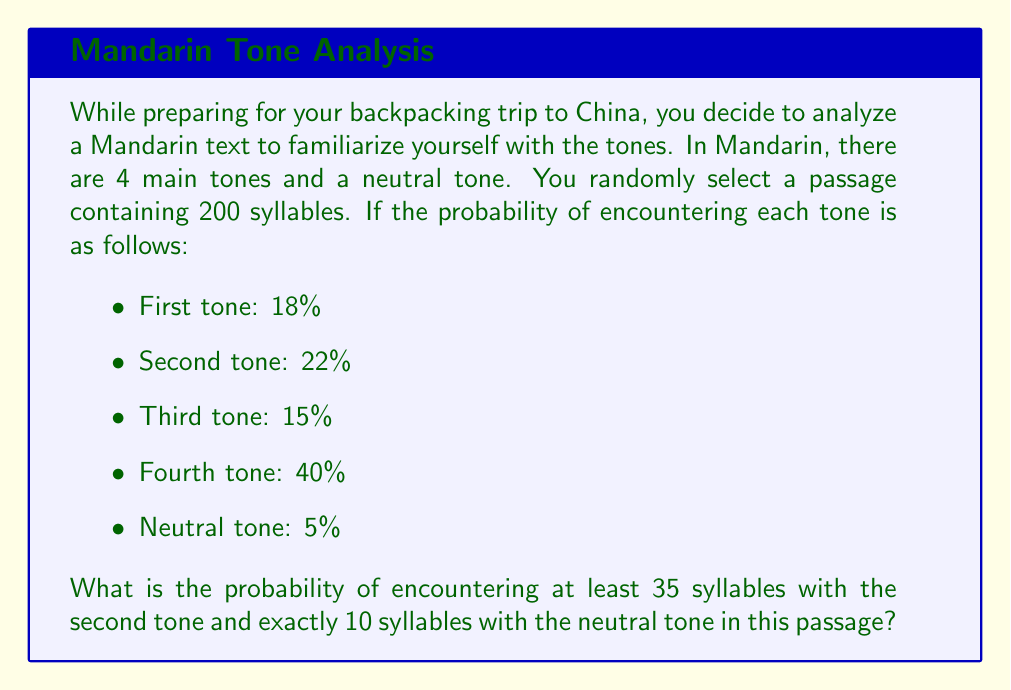Provide a solution to this math problem. Let's approach this step-by-step using the binomial distribution and the multiplication rule of probability:

1) For the second tone:
   - We want at least 35 syllables out of 200
   - Probability of second tone = 22% = 0.22
   - Let X be the number of second tone syllables
   
   P(X ≥ 35) = 1 - P(X < 35)
   
   We can calculate this using the cumulative binomial distribution:
   
   $$P(X \geq 35) = 1 - \sum_{k=0}^{34} \binom{200}{k} (0.22)^k (0.78)^{200-k}$$

2) For the neutral tone:
   - We want exactly 10 syllables out of 200
   - Probability of neutral tone = 5% = 0.05
   - Let Y be the number of neutral tone syllables
   
   We can calculate this using the binomial probability mass function:
   
   $$P(Y = 10) = \binom{200}{10} (0.05)^{10} (0.95)^{190}$$

3) The probability of both events occurring is the product of their individual probabilities:

   $$P(\text{at least 35 second tone AND exactly 10 neutral tone}) = P(X \geq 35) \cdot P(Y = 10)$$

Calculating these probabilities:

P(X ≥ 35) ≈ 0.9761
P(Y = 10) ≈ 0.0437

Therefore, the final probability is:

$$0.9761 \cdot 0.0437 \approx 0.0427$$
Answer: 0.0427 